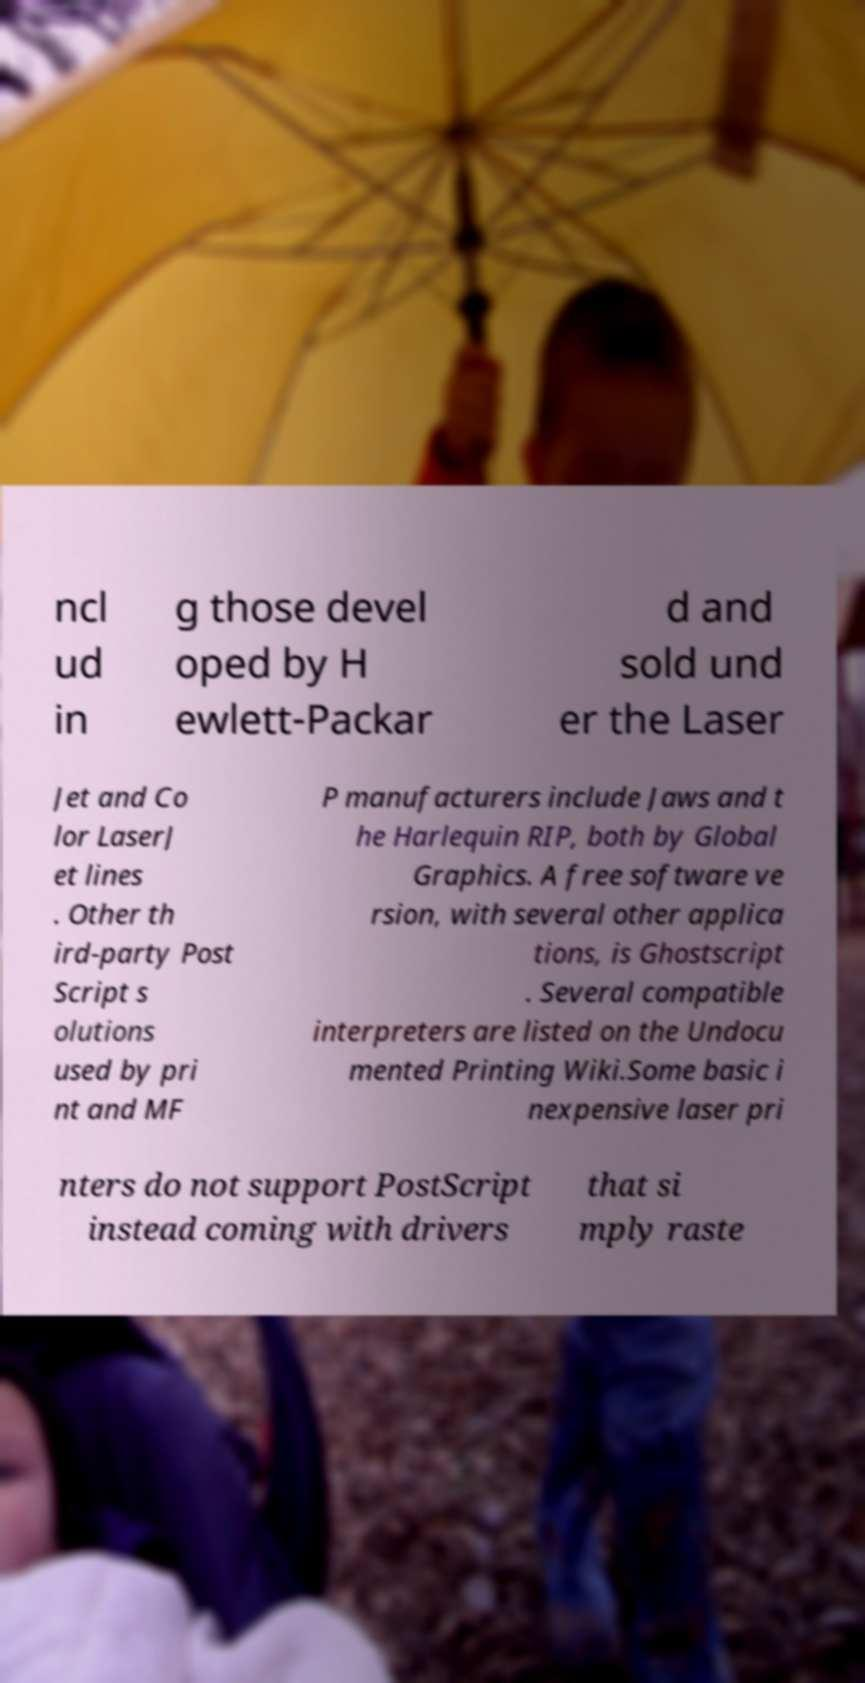Can you accurately transcribe the text from the provided image for me? ncl ud in g those devel oped by H ewlett-Packar d and sold und er the Laser Jet and Co lor LaserJ et lines . Other th ird-party Post Script s olutions used by pri nt and MF P manufacturers include Jaws and t he Harlequin RIP, both by Global Graphics. A free software ve rsion, with several other applica tions, is Ghostscript . Several compatible interpreters are listed on the Undocu mented Printing Wiki.Some basic i nexpensive laser pri nters do not support PostScript instead coming with drivers that si mply raste 